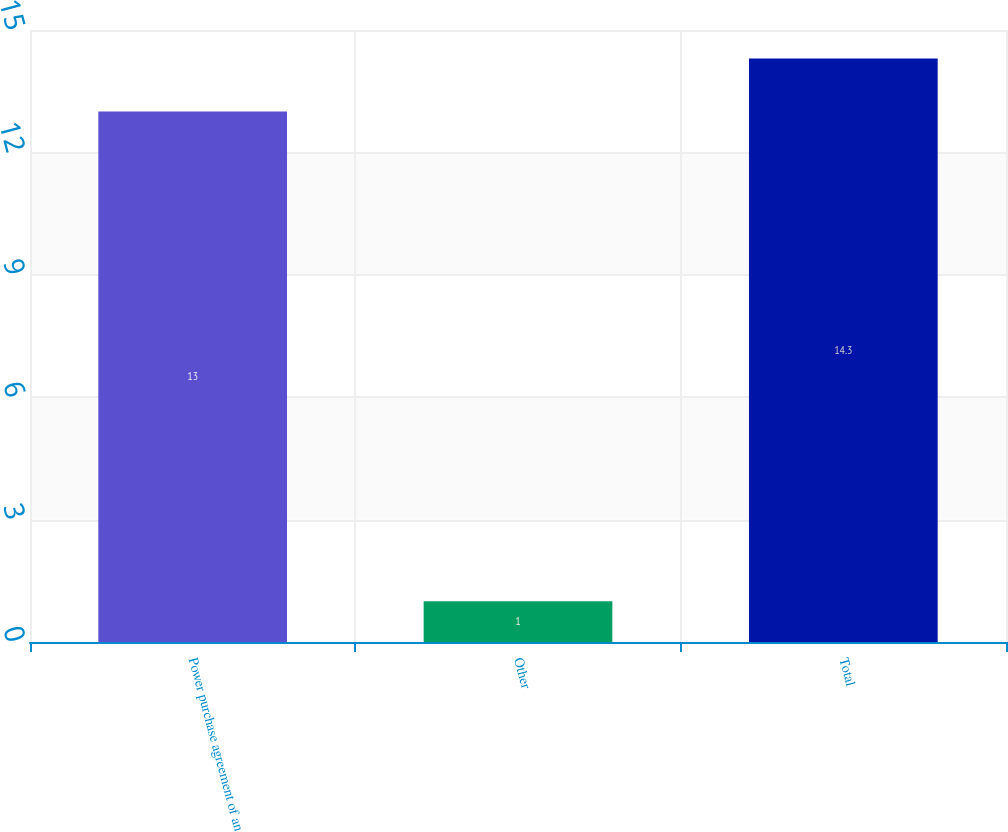Convert chart. <chart><loc_0><loc_0><loc_500><loc_500><bar_chart><fcel>Power purchase agreement of an<fcel>Other<fcel>Total<nl><fcel>13<fcel>1<fcel>14.3<nl></chart> 